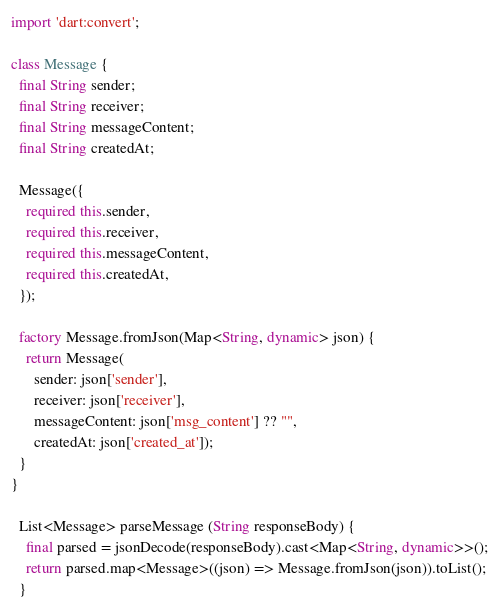<code> <loc_0><loc_0><loc_500><loc_500><_Dart_>
import 'dart:convert';

class Message {
  final String sender;
  final String receiver;
  final String messageContent;
  final String createdAt;

  Message({
    required this.sender,
    required this.receiver,
    required this.messageContent,
    required this.createdAt,
  });

  factory Message.fromJson(Map<String, dynamic> json) {
    return Message(
      sender: json['sender'],
      receiver: json['receiver'],
      messageContent: json['msg_content'] ?? "",
      createdAt: json['created_at']);
  }
}  
  
  List<Message> parseMessage (String responseBody) {
    final parsed = jsonDecode(responseBody).cast<Map<String, dynamic>>();
    return parsed.map<Message>((json) => Message.fromJson(json)).toList();
  }


</code> 